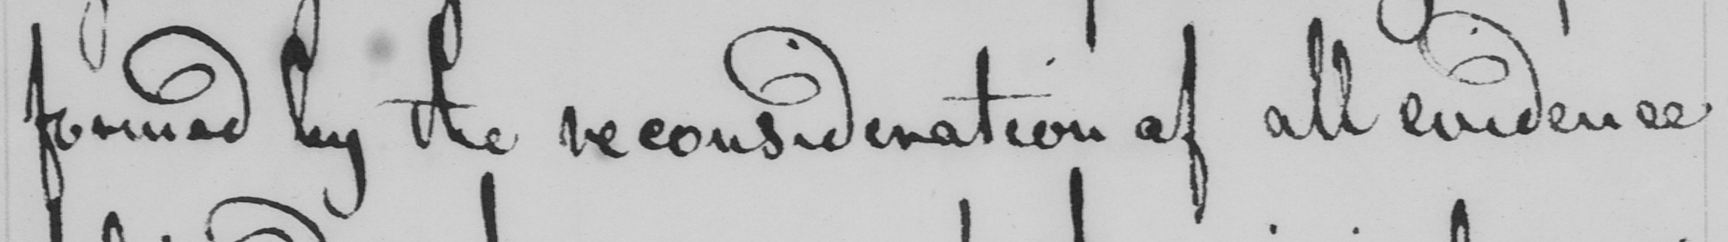What does this handwritten line say? formed by the reconsideration of all evidence 